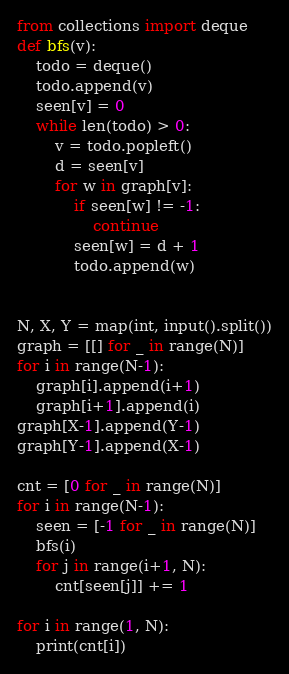<code> <loc_0><loc_0><loc_500><loc_500><_Python_>from collections import deque
def bfs(v):
    todo = deque()
    todo.append(v)
    seen[v] = 0
    while len(todo) > 0:
        v = todo.popleft()
        d = seen[v]
        for w in graph[v]:
            if seen[w] != -1:
                continue
            seen[w] = d + 1
            todo.append(w)


N, X, Y = map(int, input().split())
graph = [[] for _ in range(N)]
for i in range(N-1):
    graph[i].append(i+1)
    graph[i+1].append(i)
graph[X-1].append(Y-1)
graph[Y-1].append(X-1)

cnt = [0 for _ in range(N)]
for i in range(N-1):
    seen = [-1 for _ in range(N)]
    bfs(i)
    for j in range(i+1, N):
        cnt[seen[j]] += 1

for i in range(1, N):
    print(cnt[i])</code> 